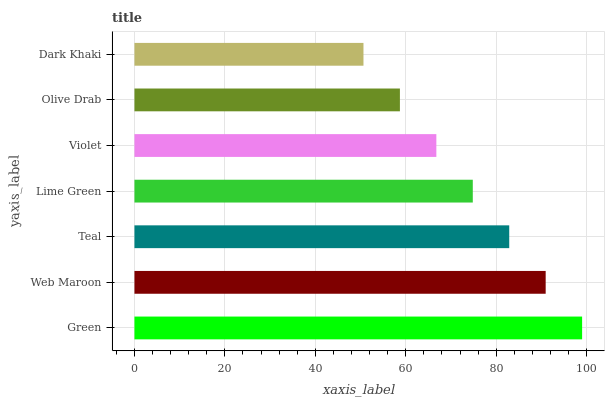Is Dark Khaki the minimum?
Answer yes or no. Yes. Is Green the maximum?
Answer yes or no. Yes. Is Web Maroon the minimum?
Answer yes or no. No. Is Web Maroon the maximum?
Answer yes or no. No. Is Green greater than Web Maroon?
Answer yes or no. Yes. Is Web Maroon less than Green?
Answer yes or no. Yes. Is Web Maroon greater than Green?
Answer yes or no. No. Is Green less than Web Maroon?
Answer yes or no. No. Is Lime Green the high median?
Answer yes or no. Yes. Is Lime Green the low median?
Answer yes or no. Yes. Is Teal the high median?
Answer yes or no. No. Is Violet the low median?
Answer yes or no. No. 